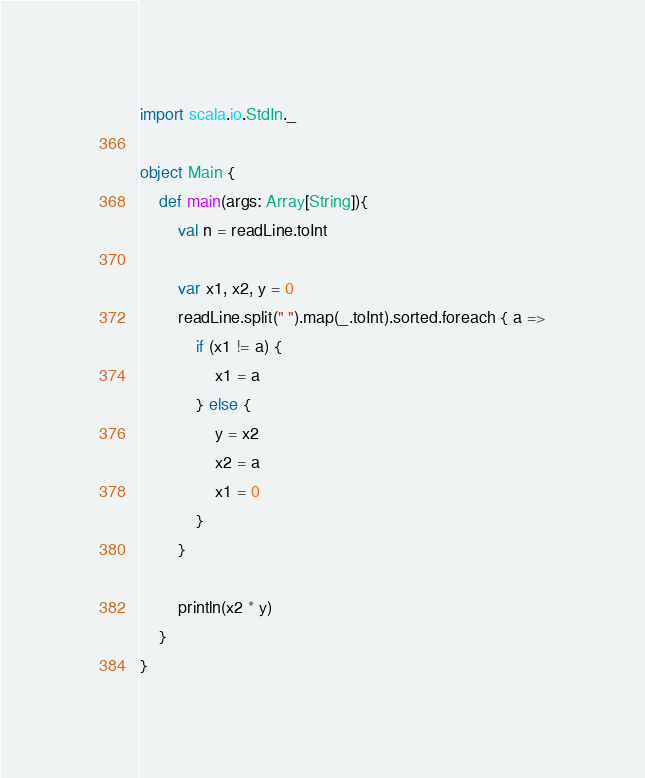Convert code to text. <code><loc_0><loc_0><loc_500><loc_500><_Scala_>import scala.io.StdIn._

object Main {
    def main(args: Array[String]){
        val n = readLine.toInt
        
        var x1, x2, y = 0
        readLine.split(" ").map(_.toInt).sorted.foreach { a =>
            if (x1 != a) {
                x1 = a
            } else {
                y = x2
                x2 = a
                x1 = 0
            }
        }
        
        println(x2 * y)
    }
}</code> 